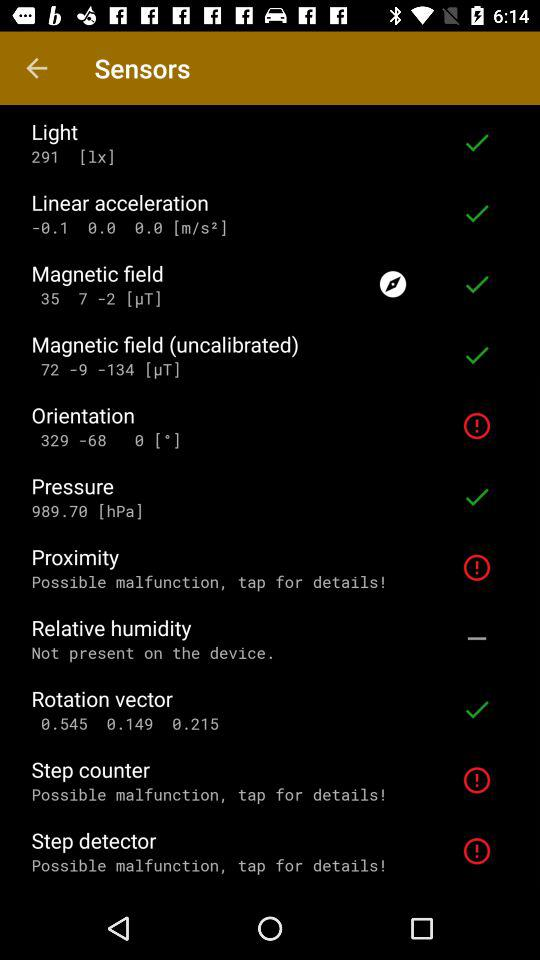Is "Relative humidity" present or not? It is not present. 